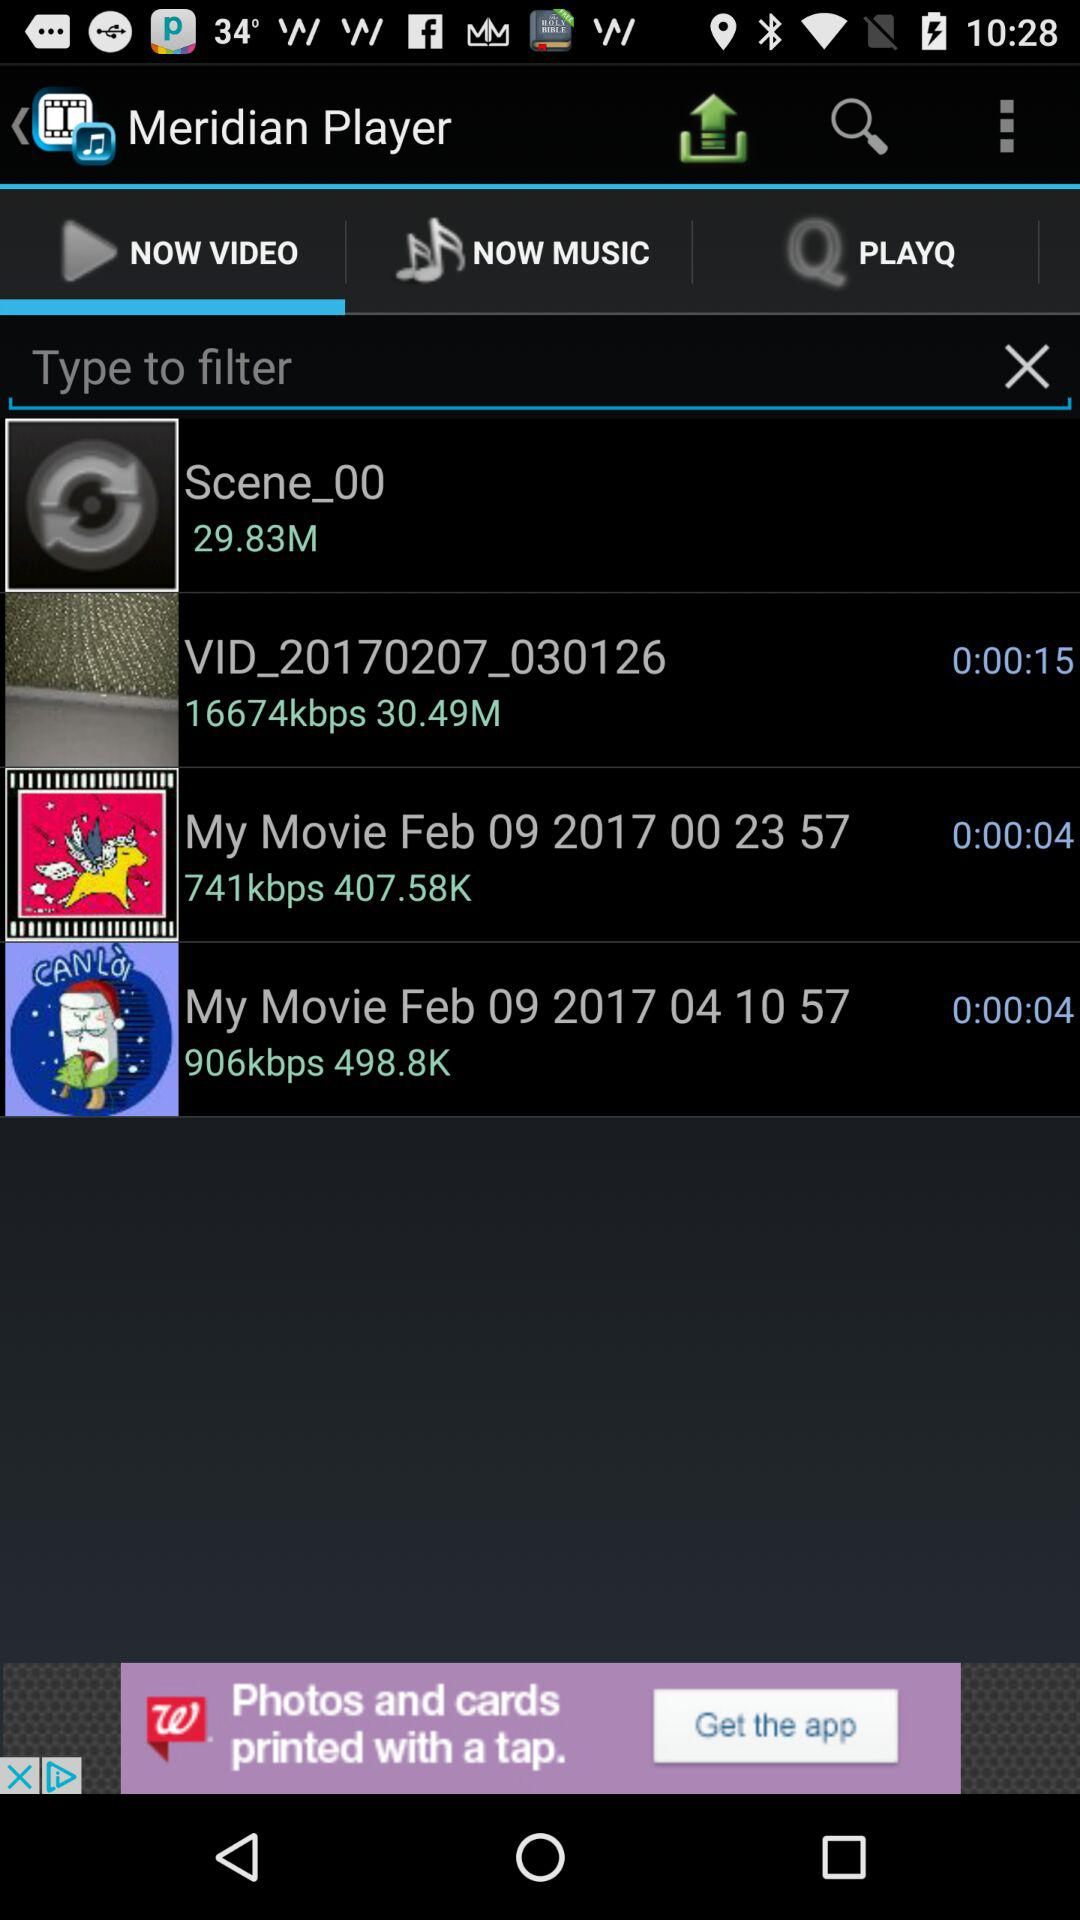What's the file size of "Scene_00"? The file size of "Scene_00" is 29.83M. 